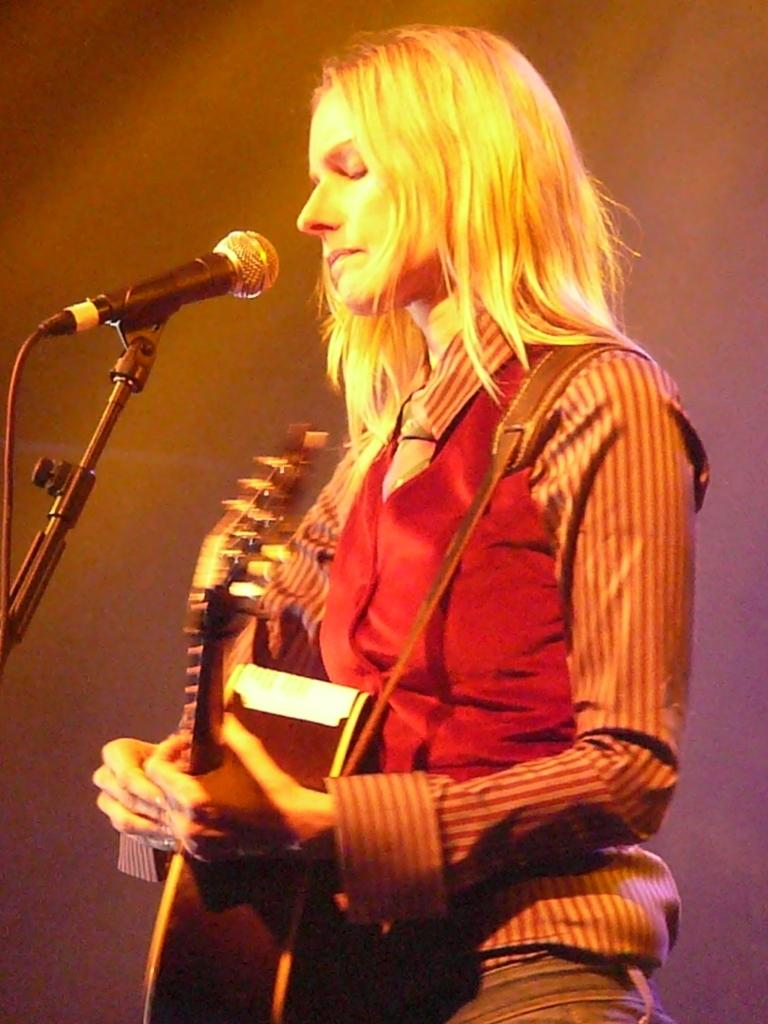Who is the main subject in the image? There is a woman in the image. What is the woman doing in the image? The woman is standing in front of a microphone and playing a guitar. What type of sticks can be seen in the woman's hands in the image? There are no sticks visible in the woman's hands in the image; she is holding a guitar. 